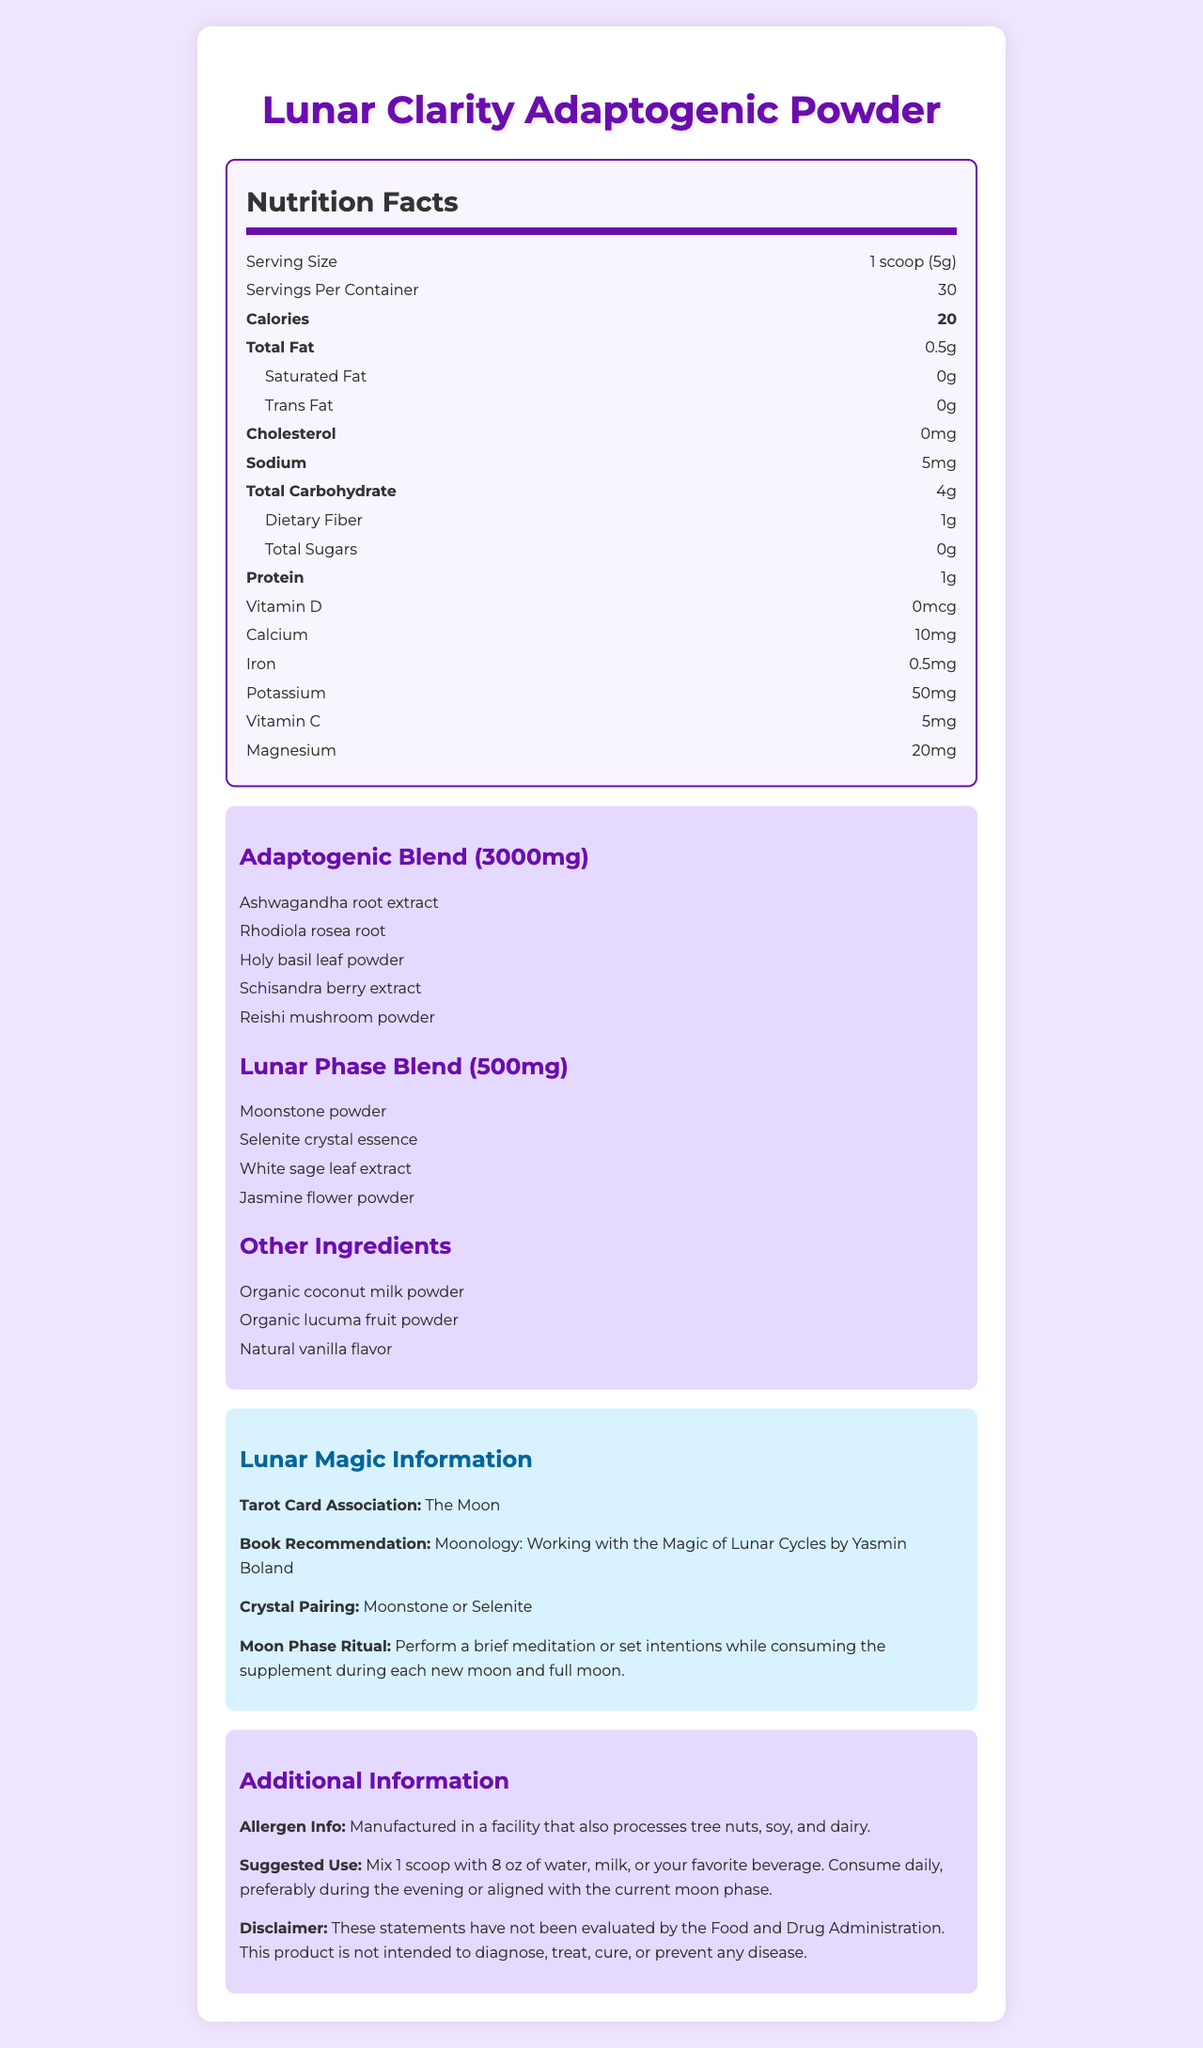What is the serving size of the Lunar Clarity Adaptogenic Powder? The serving size is clearly listed as "1 scoop (5g)" on the nutrition label.
Answer: 1 scoop (5g) How many servings are there per container? The label states that there are 30 servings per container.
Answer: 30 How many calories are there per serving? It mentions the amount of calories per serving as 20 calories.
Answer: 20 What is the total amount of adaptogenic blend per serving? The label specifies an adaptogenic blend of 3000mg per serving.
Answer: 3000mg List some of the ingredients in the lunar phase blend. The label lists the lunar phase ingredients as Moonstone powder, Selenite crystal essence, White sage leaf extract, and Jasmine flower powder.
Answer: Moonstone powder, Selenite crystal essence, White sage leaf extract, Jasmine flower powder What is the tarot card association of the product? The lunar magic information section specifies the tarot card association as "The Moon."
Answer: The Moon Which crystal is recommended for pairing with this adaptogenic powder? A. Rose Quartz B. Moonstone C. Amethyst D. Citrine The document suggests Moonstone as one of the crystal pairings.
Answer: B. Moonstone What vitamin does this adaptogenic powder not contain? A. Vitamin D B. Vitamin C C. Vitamin A D. Vitamin B12 The nutrition facts list Vitamin D and Vitamin C but do not mention Vitamin A or B12, so A and B are incorrect. Vitamin A is the one not listed.
Answer: C. Vitamin A Is there any cholesterol in this product? The nutrition facts state that the cholesterol content is 0mg.
Answer: No Summarize the document. The document provides detailed information about the product's nutritional value, ingredients, suggested use, and associated metaphysical properties, concluding with allergen information and disclaimers.
Answer: The Lunar Clarity Adaptogenic Powder is a nutritional supplement aligned with moon phases, containing a blend of adaptogenic and lunar phase ingredients. It has a serving size of 1 scoop (5g) with 30 servings per container. The nutrition label lists various nutritional facts, including 20 calories per serving, 0.5g total fat, 4g total carbohydrate, and 1g protein. Key ingredients include Ashwagandha, Rhodiola, and Moonstone powder. It is recommended to consume this supplement in alignment with moon phases, with additional associations to The Moon tarot card, Moonstone crystals, and moon phase rituals. What are the suggested usage instructions for the supplement? The suggested use section specifies mixing 1 scoop with 8 oz of liquid and consuming daily, ideally in the evening or aligned with the moon phase.
Answer: Mix 1 scoop with 8 oz of water, milk, or your favorite beverage. Consume daily, preferably during the evening or aligned with the current moon phase. Can you determine the manufacturing facility's exact location based on the document? The document does not provide specific information about the manufacturing facility's location. It only states that the facility processes tree nuts, soy, and dairy.
Answer: Cannot be determined 